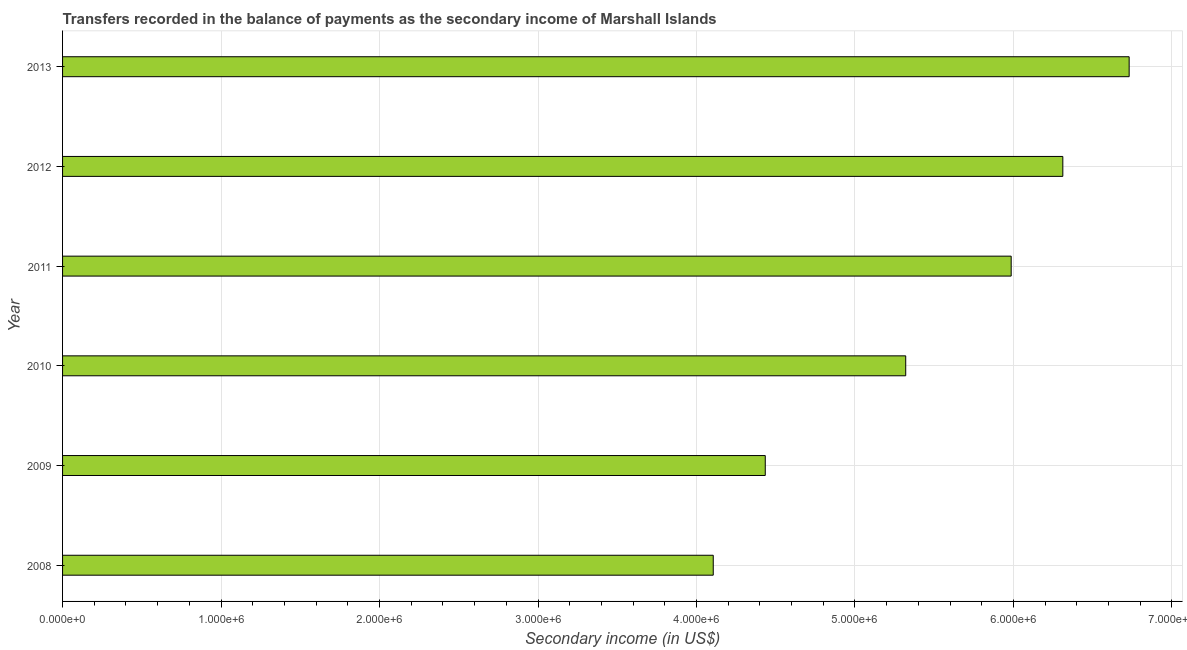What is the title of the graph?
Ensure brevity in your answer.  Transfers recorded in the balance of payments as the secondary income of Marshall Islands. What is the label or title of the X-axis?
Give a very brief answer. Secondary income (in US$). What is the label or title of the Y-axis?
Your answer should be very brief. Year. What is the amount of secondary income in 2012?
Your answer should be compact. 6.31e+06. Across all years, what is the maximum amount of secondary income?
Offer a terse response. 6.73e+06. Across all years, what is the minimum amount of secondary income?
Offer a terse response. 4.11e+06. In which year was the amount of secondary income minimum?
Offer a very short reply. 2008. What is the sum of the amount of secondary income?
Your response must be concise. 3.29e+07. What is the difference between the amount of secondary income in 2008 and 2012?
Your answer should be compact. -2.21e+06. What is the average amount of secondary income per year?
Your answer should be compact. 5.48e+06. What is the median amount of secondary income?
Provide a short and direct response. 5.65e+06. In how many years, is the amount of secondary income greater than 4400000 US$?
Offer a very short reply. 5. Do a majority of the years between 2009 and 2011 (inclusive) have amount of secondary income greater than 4400000 US$?
Your response must be concise. Yes. What is the ratio of the amount of secondary income in 2009 to that in 2010?
Your response must be concise. 0.83. Is the amount of secondary income in 2010 less than that in 2012?
Provide a succinct answer. Yes. Is the difference between the amount of secondary income in 2008 and 2012 greater than the difference between any two years?
Offer a terse response. No. What is the difference between the highest and the second highest amount of secondary income?
Offer a very short reply. 4.19e+05. What is the difference between the highest and the lowest amount of secondary income?
Your answer should be very brief. 2.62e+06. In how many years, is the amount of secondary income greater than the average amount of secondary income taken over all years?
Offer a very short reply. 3. How many years are there in the graph?
Give a very brief answer. 6. Are the values on the major ticks of X-axis written in scientific E-notation?
Provide a short and direct response. Yes. What is the Secondary income (in US$) in 2008?
Make the answer very short. 4.11e+06. What is the Secondary income (in US$) of 2009?
Offer a very short reply. 4.43e+06. What is the Secondary income (in US$) of 2010?
Keep it short and to the point. 5.32e+06. What is the Secondary income (in US$) of 2011?
Your answer should be very brief. 5.99e+06. What is the Secondary income (in US$) of 2012?
Keep it short and to the point. 6.31e+06. What is the Secondary income (in US$) of 2013?
Provide a succinct answer. 6.73e+06. What is the difference between the Secondary income (in US$) in 2008 and 2009?
Give a very brief answer. -3.28e+05. What is the difference between the Secondary income (in US$) in 2008 and 2010?
Your response must be concise. -1.21e+06. What is the difference between the Secondary income (in US$) in 2008 and 2011?
Your answer should be very brief. -1.88e+06. What is the difference between the Secondary income (in US$) in 2008 and 2012?
Make the answer very short. -2.21e+06. What is the difference between the Secondary income (in US$) in 2008 and 2013?
Keep it short and to the point. -2.62e+06. What is the difference between the Secondary income (in US$) in 2009 and 2010?
Keep it short and to the point. -8.86e+05. What is the difference between the Secondary income (in US$) in 2009 and 2011?
Ensure brevity in your answer.  -1.55e+06. What is the difference between the Secondary income (in US$) in 2009 and 2012?
Provide a short and direct response. -1.88e+06. What is the difference between the Secondary income (in US$) in 2009 and 2013?
Give a very brief answer. -2.30e+06. What is the difference between the Secondary income (in US$) in 2010 and 2011?
Make the answer very short. -6.65e+05. What is the difference between the Secondary income (in US$) in 2010 and 2012?
Give a very brief answer. -9.91e+05. What is the difference between the Secondary income (in US$) in 2010 and 2013?
Ensure brevity in your answer.  -1.41e+06. What is the difference between the Secondary income (in US$) in 2011 and 2012?
Make the answer very short. -3.26e+05. What is the difference between the Secondary income (in US$) in 2011 and 2013?
Keep it short and to the point. -7.44e+05. What is the difference between the Secondary income (in US$) in 2012 and 2013?
Your answer should be compact. -4.19e+05. What is the ratio of the Secondary income (in US$) in 2008 to that in 2009?
Offer a terse response. 0.93. What is the ratio of the Secondary income (in US$) in 2008 to that in 2010?
Your answer should be very brief. 0.77. What is the ratio of the Secondary income (in US$) in 2008 to that in 2011?
Your response must be concise. 0.69. What is the ratio of the Secondary income (in US$) in 2008 to that in 2012?
Your response must be concise. 0.65. What is the ratio of the Secondary income (in US$) in 2008 to that in 2013?
Your answer should be very brief. 0.61. What is the ratio of the Secondary income (in US$) in 2009 to that in 2010?
Your answer should be very brief. 0.83. What is the ratio of the Secondary income (in US$) in 2009 to that in 2011?
Make the answer very short. 0.74. What is the ratio of the Secondary income (in US$) in 2009 to that in 2012?
Your response must be concise. 0.7. What is the ratio of the Secondary income (in US$) in 2009 to that in 2013?
Ensure brevity in your answer.  0.66. What is the ratio of the Secondary income (in US$) in 2010 to that in 2011?
Offer a very short reply. 0.89. What is the ratio of the Secondary income (in US$) in 2010 to that in 2012?
Your answer should be compact. 0.84. What is the ratio of the Secondary income (in US$) in 2010 to that in 2013?
Provide a short and direct response. 0.79. What is the ratio of the Secondary income (in US$) in 2011 to that in 2012?
Your answer should be very brief. 0.95. What is the ratio of the Secondary income (in US$) in 2011 to that in 2013?
Keep it short and to the point. 0.89. What is the ratio of the Secondary income (in US$) in 2012 to that in 2013?
Your response must be concise. 0.94. 